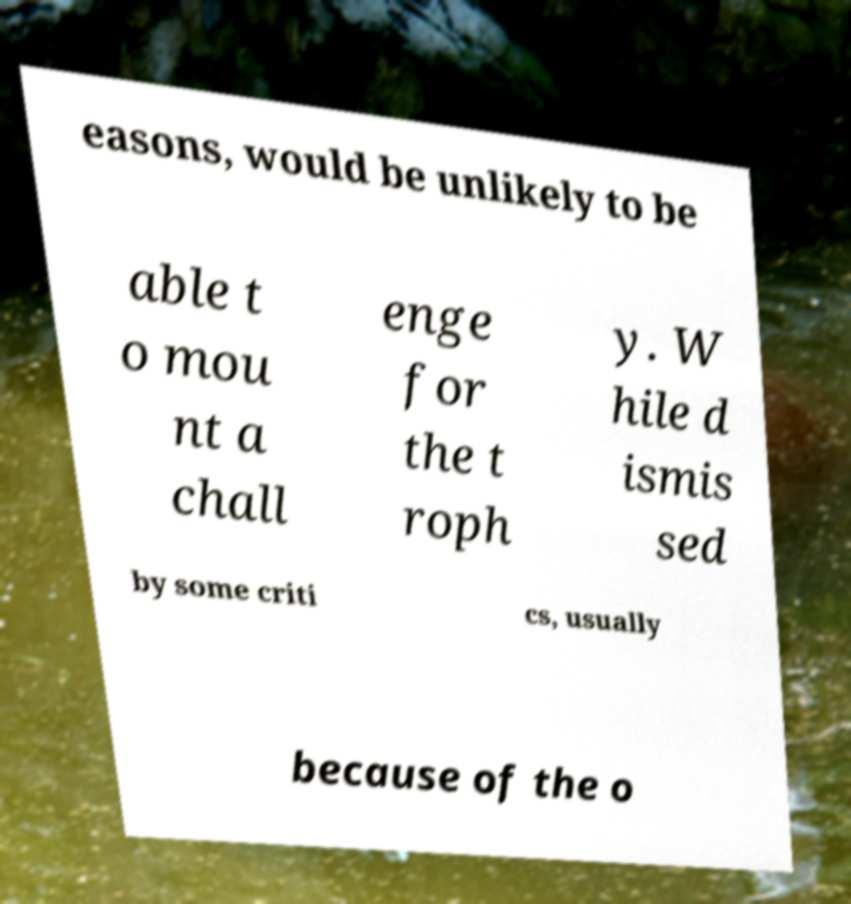Can you read and provide the text displayed in the image?This photo seems to have some interesting text. Can you extract and type it out for me? easons, would be unlikely to be able t o mou nt a chall enge for the t roph y. W hile d ismis sed by some criti cs, usually because of the o 